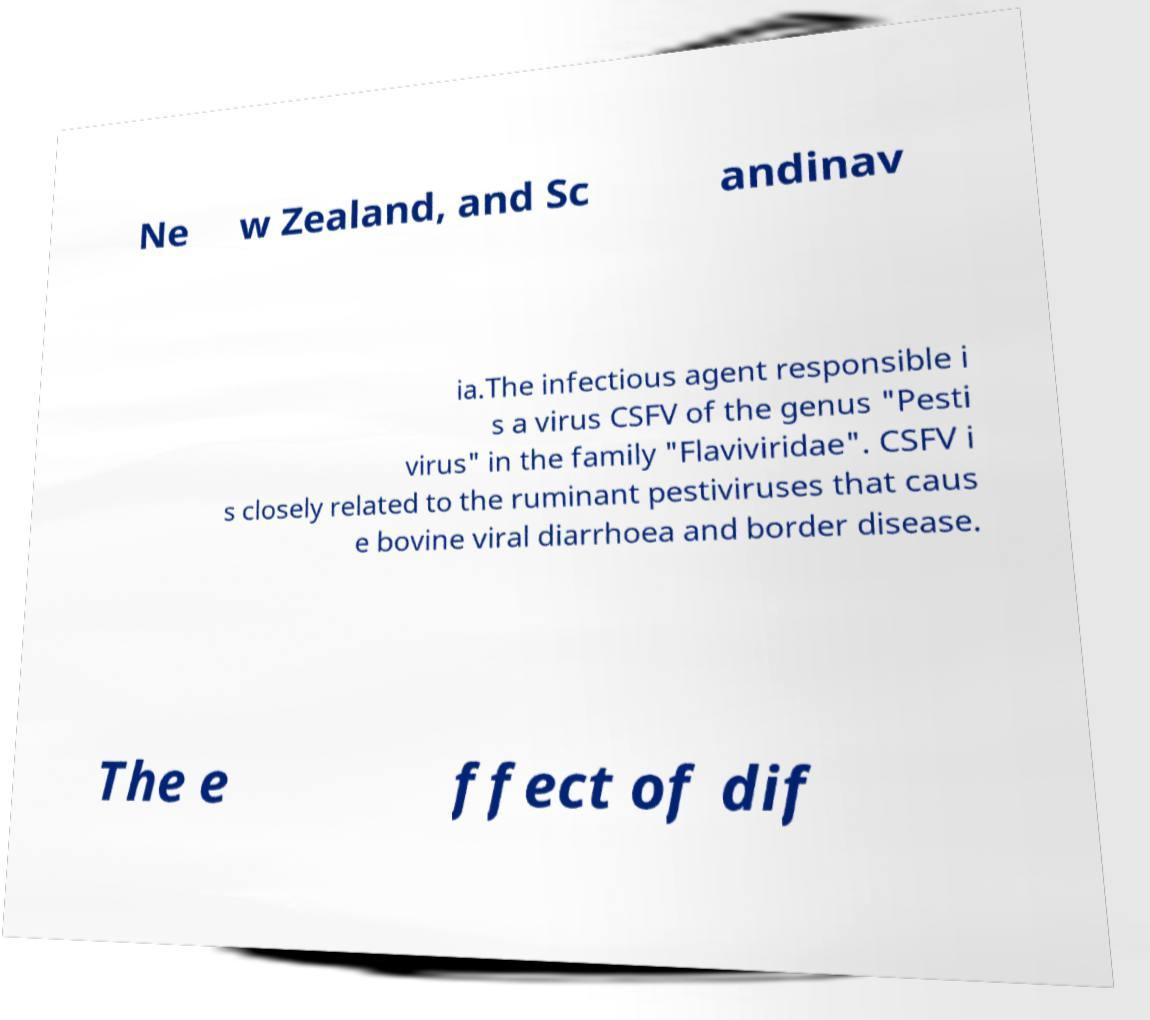Please identify and transcribe the text found in this image. Ne w Zealand, and Sc andinav ia.The infectious agent responsible i s a virus CSFV of the genus "Pesti virus" in the family "Flaviviridae". CSFV i s closely related to the ruminant pestiviruses that caus e bovine viral diarrhoea and border disease. The e ffect of dif 